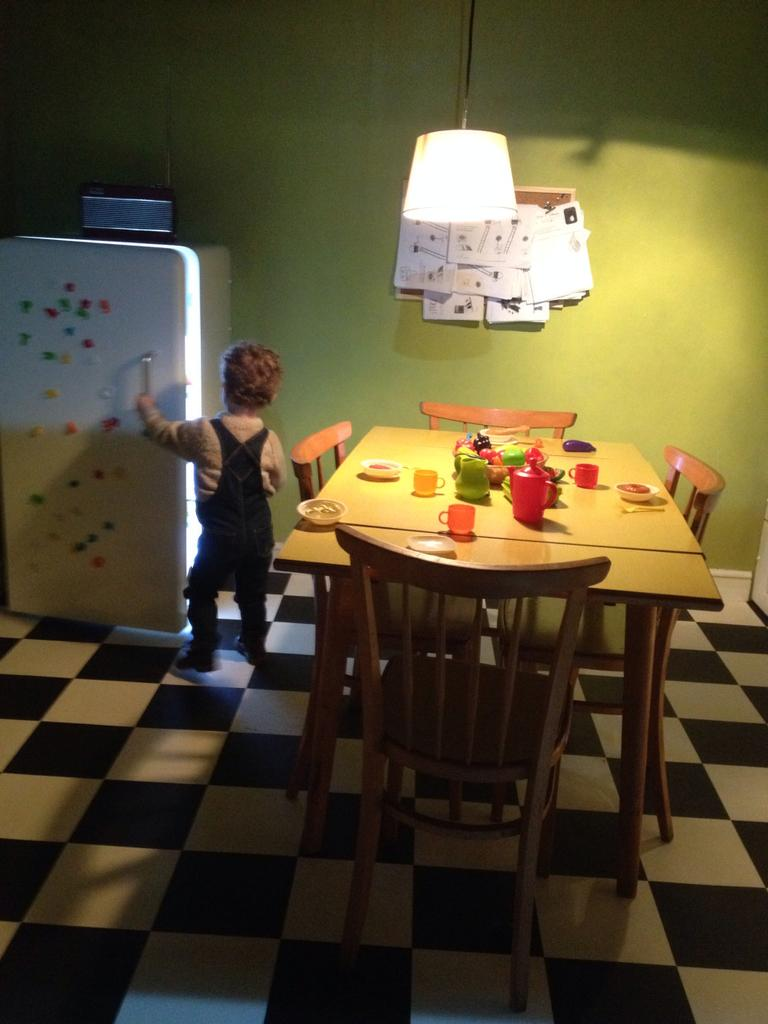What is the main subject of the image? There is a boy standing in the image. What objects are on the table in the image? There are bottles and cups on the table in the image. What type of vegetation can be seen in the image? There are trees visible in the image. What type of authority figure can be seen in the image? There is no authority figure present in the image; it features a boy standing and objects on a table. How many oranges are visible in the image? There are no oranges present in the image. 